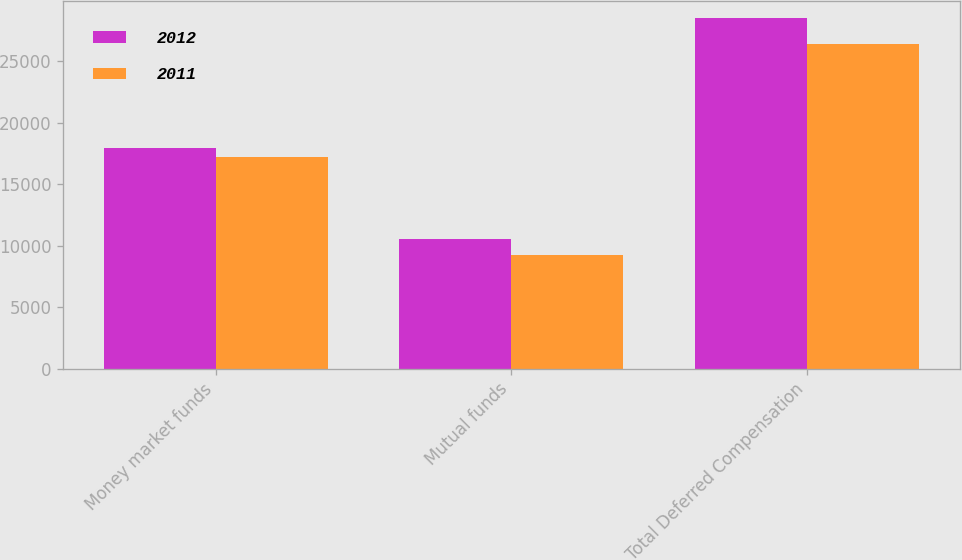Convert chart. <chart><loc_0><loc_0><loc_500><loc_500><stacked_bar_chart><ecel><fcel>Money market funds<fcel>Mutual funds<fcel>Total Deferred Compensation<nl><fcel>2012<fcel>17939<fcel>10541<fcel>28480<nl><fcel>2011<fcel>17187<fcel>9223<fcel>26410<nl></chart> 